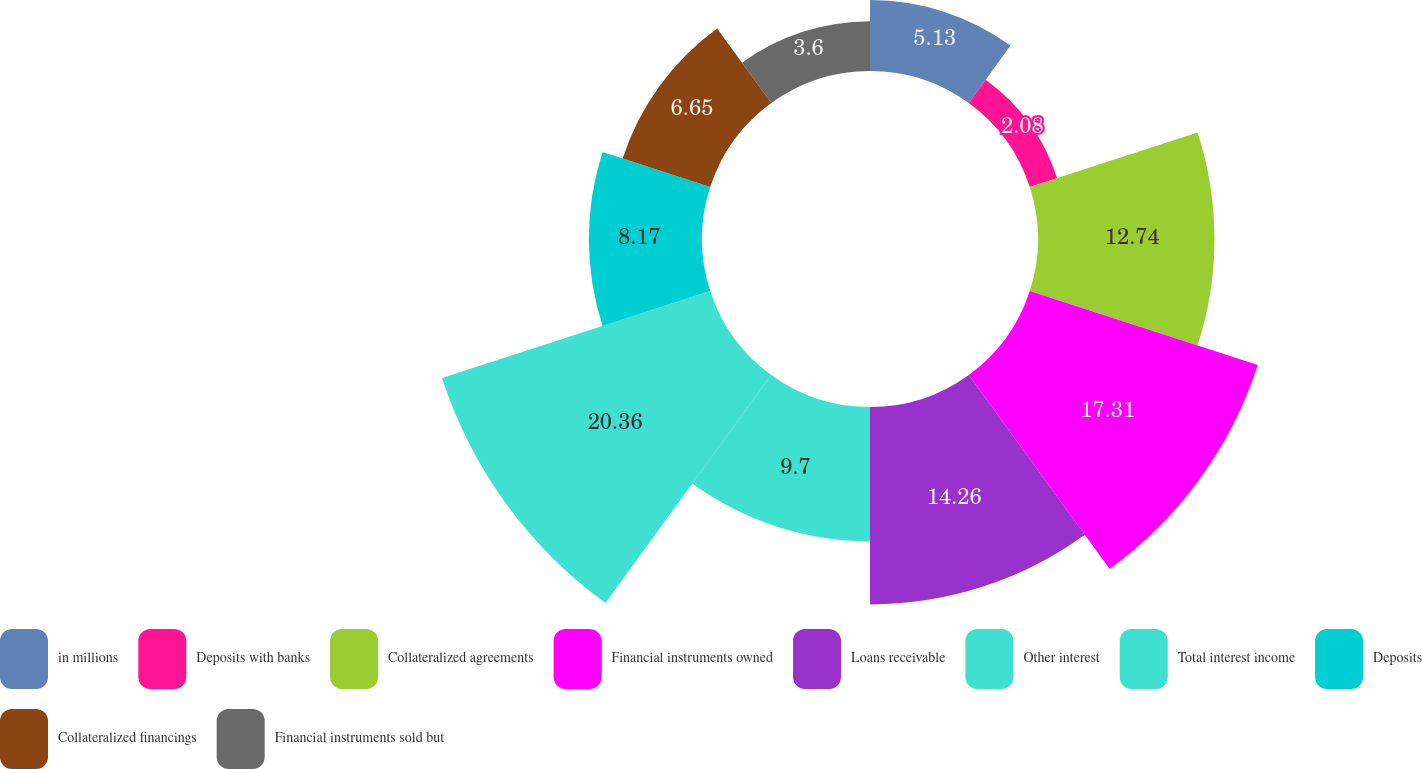Convert chart to OTSL. <chart><loc_0><loc_0><loc_500><loc_500><pie_chart><fcel>in millions<fcel>Deposits with banks<fcel>Collateralized agreements<fcel>Financial instruments owned<fcel>Loans receivable<fcel>Other interest<fcel>Total interest income<fcel>Deposits<fcel>Collateralized financings<fcel>Financial instruments sold but<nl><fcel>5.13%<fcel>2.08%<fcel>12.74%<fcel>17.31%<fcel>14.26%<fcel>9.7%<fcel>20.36%<fcel>8.17%<fcel>6.65%<fcel>3.6%<nl></chart> 